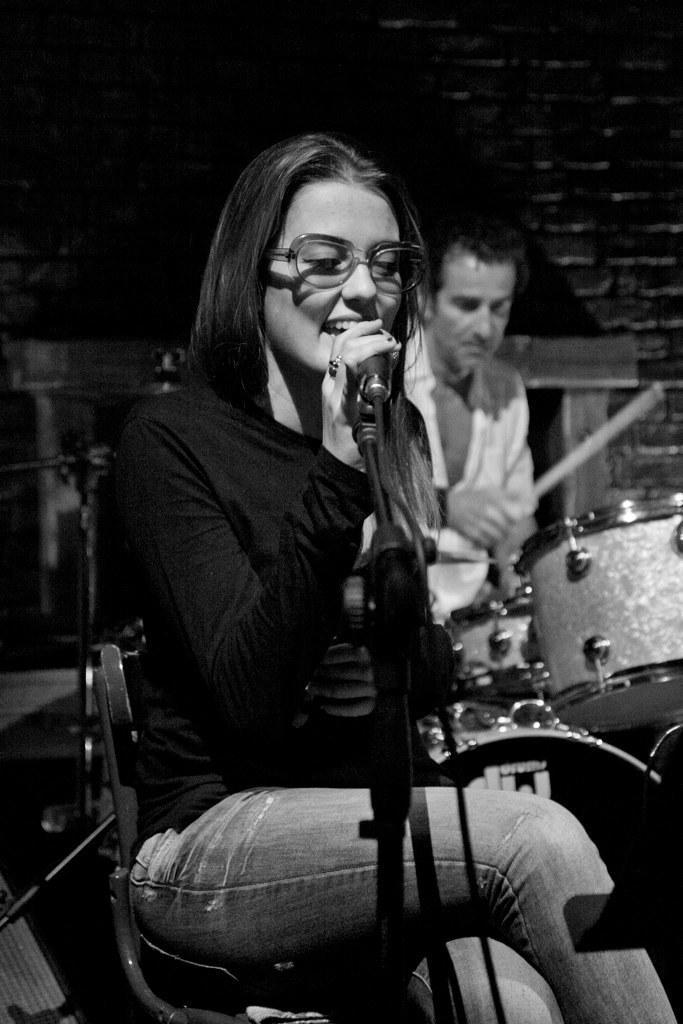How would you summarize this image in a sentence or two? It is a black and white image. In this image in front there is a person sitting on the chair and she is holding the mike. Behind her there is another person playing musical instruments. In the background of the image there is a wall. 